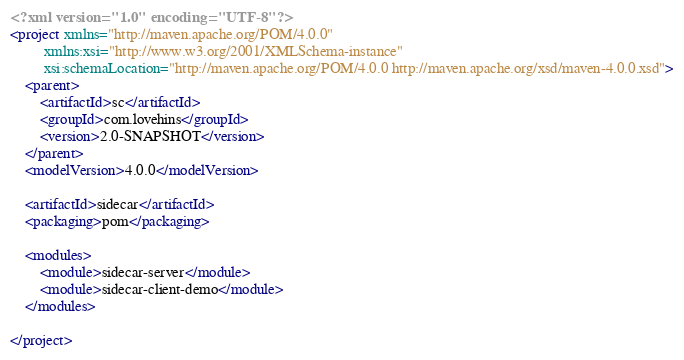<code> <loc_0><loc_0><loc_500><loc_500><_XML_><?xml version="1.0" encoding="UTF-8"?>
<project xmlns="http://maven.apache.org/POM/4.0.0"
         xmlns:xsi="http://www.w3.org/2001/XMLSchema-instance"
         xsi:schemaLocation="http://maven.apache.org/POM/4.0.0 http://maven.apache.org/xsd/maven-4.0.0.xsd">
    <parent>
        <artifactId>sc</artifactId>
        <groupId>com.lovehins</groupId>
        <version>2.0-SNAPSHOT</version>
    </parent>
    <modelVersion>4.0.0</modelVersion>

    <artifactId>sidecar</artifactId>
    <packaging>pom</packaging>

    <modules>
        <module>sidecar-server</module>
        <module>sidecar-client-demo</module>
    </modules>

</project></code> 